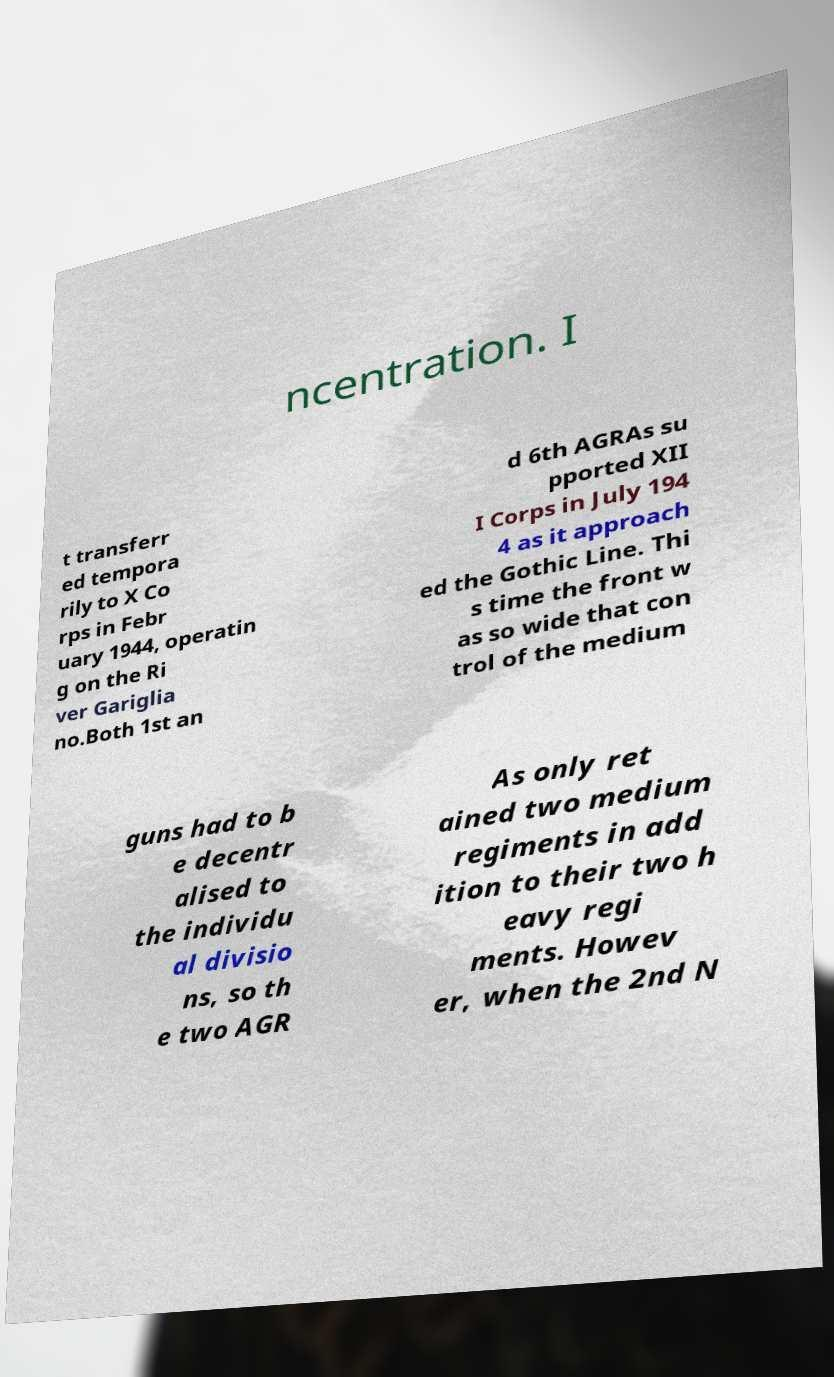There's text embedded in this image that I need extracted. Can you transcribe it verbatim? ncentration. I t transferr ed tempora rily to X Co rps in Febr uary 1944, operatin g on the Ri ver Gariglia no.Both 1st an d 6th AGRAs su pported XII I Corps in July 194 4 as it approach ed the Gothic Line. Thi s time the front w as so wide that con trol of the medium guns had to b e decentr alised to the individu al divisio ns, so th e two AGR As only ret ained two medium regiments in add ition to their two h eavy regi ments. Howev er, when the 2nd N 